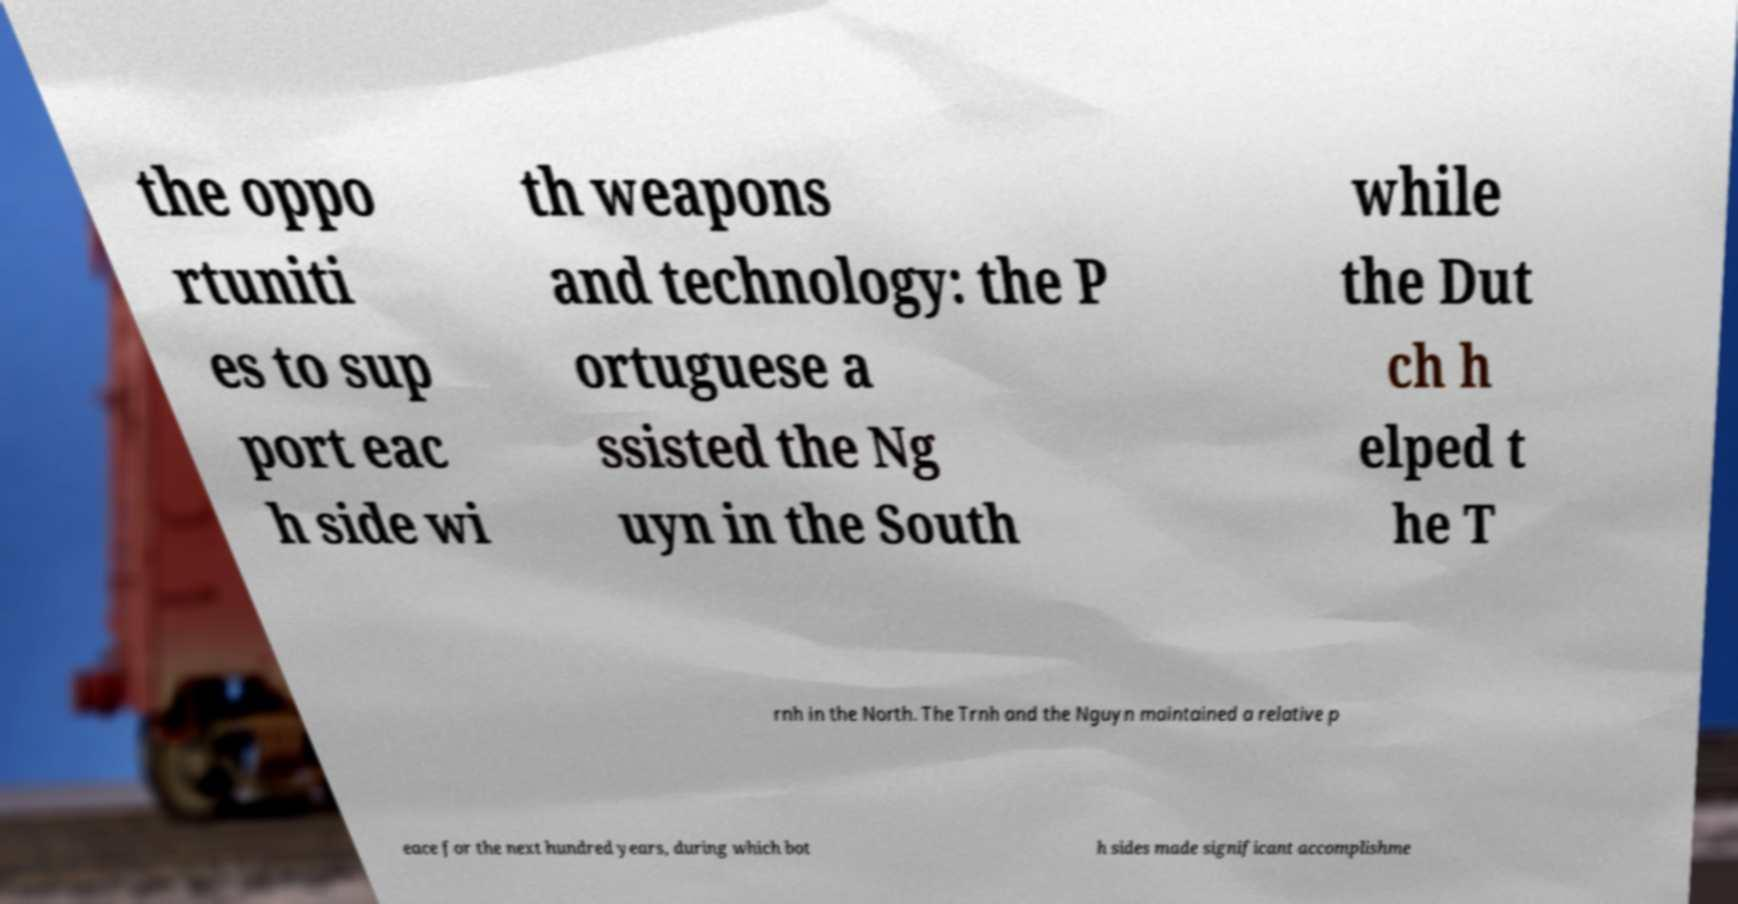Could you assist in decoding the text presented in this image and type it out clearly? the oppo rtuniti es to sup port eac h side wi th weapons and technology: the P ortuguese a ssisted the Ng uyn in the South while the Dut ch h elped t he T rnh in the North. The Trnh and the Nguyn maintained a relative p eace for the next hundred years, during which bot h sides made significant accomplishme 